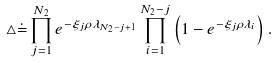<formula> <loc_0><loc_0><loc_500><loc_500>\triangle \dot { = } \prod _ { j = 1 } ^ { N _ { 2 } } e ^ { - \xi _ { j } \rho \lambda _ { N _ { 2 } - j + 1 } } \prod _ { i = 1 } ^ { N _ { 2 } - j } \left ( 1 - e ^ { - \xi _ { j } \rho \lambda _ { i } } \right ) .</formula> 